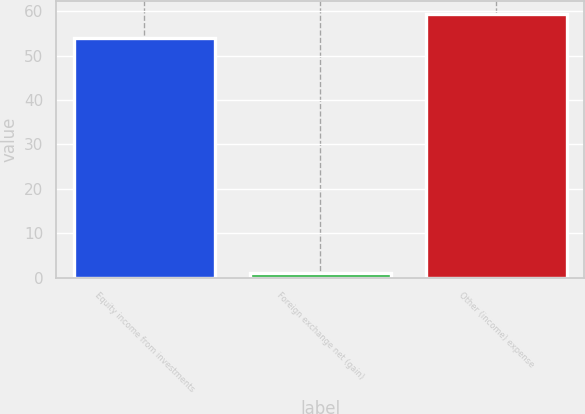<chart> <loc_0><loc_0><loc_500><loc_500><bar_chart><fcel>Equity income from investments<fcel>Foreign exchange net (gain)<fcel>Other (income) expense<nl><fcel>54<fcel>1<fcel>59.4<nl></chart> 